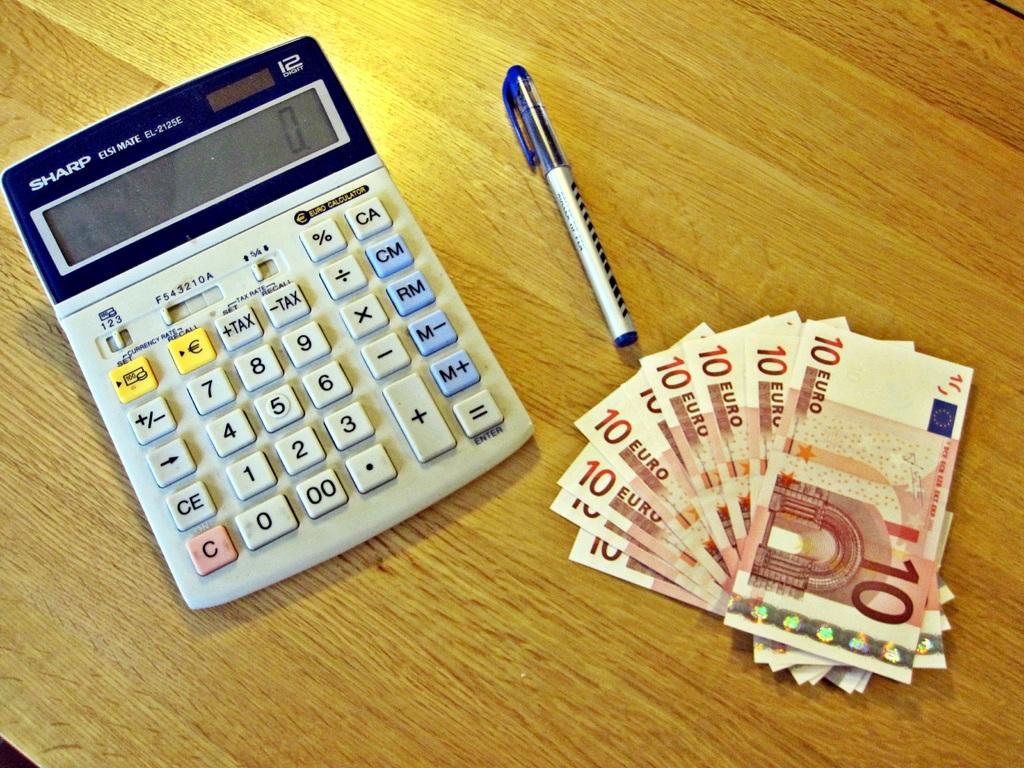Who makes the calculator?
Offer a very short reply. Sharp. Are these 10 euro bills?
Your response must be concise. Yes. 